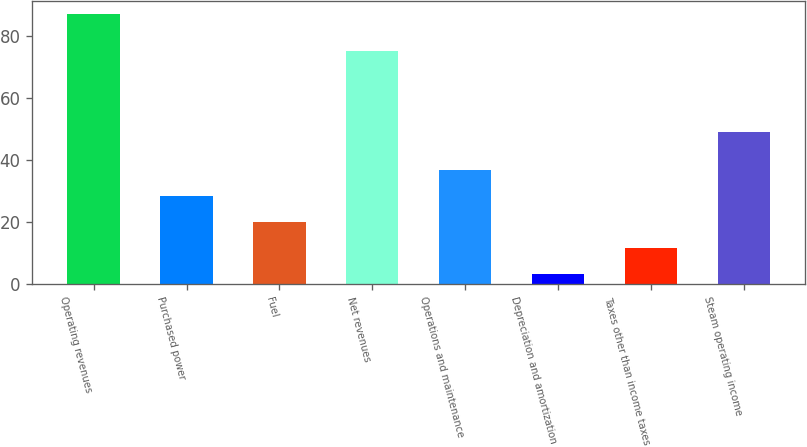Convert chart to OTSL. <chart><loc_0><loc_0><loc_500><loc_500><bar_chart><fcel>Operating revenues<fcel>Purchased power<fcel>Fuel<fcel>Net revenues<fcel>Operations and maintenance<fcel>Depreciation and amortization<fcel>Taxes other than income taxes<fcel>Steam operating income<nl><fcel>87<fcel>28.2<fcel>19.8<fcel>75<fcel>36.6<fcel>3<fcel>11.4<fcel>49<nl></chart> 